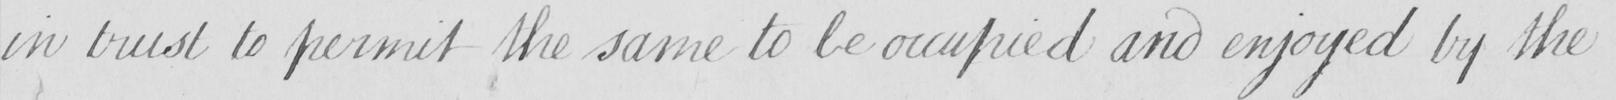Transcribe the text shown in this historical manuscript line. in trust to permit the same to be occupied and enjoyed by the 